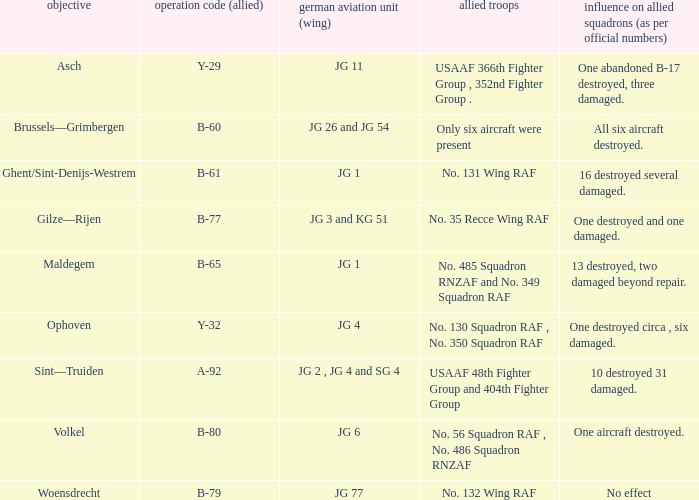Which Allied Force targetted Woensdrecht? No. 132 Wing RAF. 